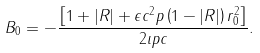Convert formula to latex. <formula><loc_0><loc_0><loc_500><loc_500>B _ { 0 } = - \frac { \left [ 1 + | R | + \epsilon c ^ { 2 } p \left ( 1 - | R | \right ) r _ { 0 } ^ { 2 } \right ] } { 2 \imath p c } .</formula> 